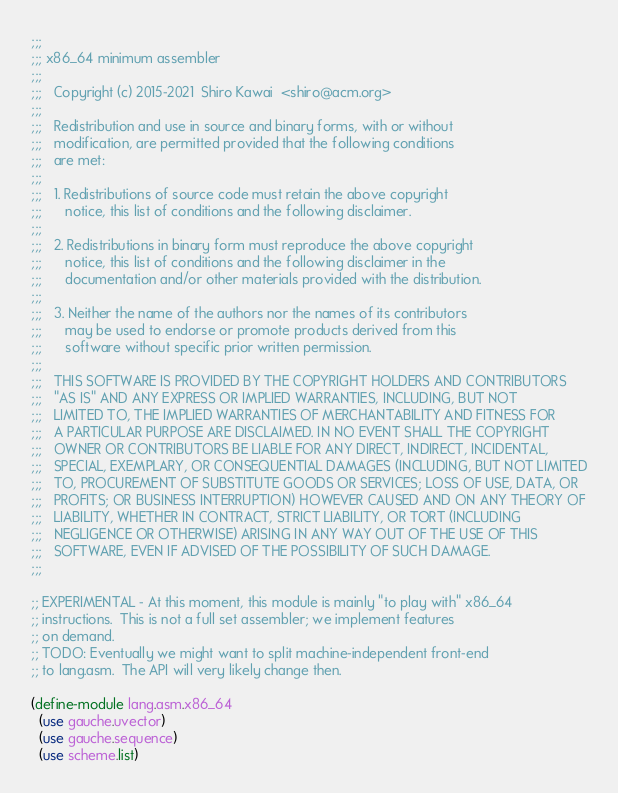<code> <loc_0><loc_0><loc_500><loc_500><_Scheme_>;;;
;;; x86_64 minimum assembler
;;;
;;;   Copyright (c) 2015-2021  Shiro Kawai  <shiro@acm.org>
;;;
;;;   Redistribution and use in source and binary forms, with or without
;;;   modification, are permitted provided that the following conditions
;;;   are met:
;;;
;;;   1. Redistributions of source code must retain the above copyright
;;;      notice, this list of conditions and the following disclaimer.
;;;
;;;   2. Redistributions in binary form must reproduce the above copyright
;;;      notice, this list of conditions and the following disclaimer in the
;;;      documentation and/or other materials provided with the distribution.
;;;
;;;   3. Neither the name of the authors nor the names of its contributors
;;;      may be used to endorse or promote products derived from this
;;;      software without specific prior written permission.
;;;
;;;   THIS SOFTWARE IS PROVIDED BY THE COPYRIGHT HOLDERS AND CONTRIBUTORS
;;;   "AS IS" AND ANY EXPRESS OR IMPLIED WARRANTIES, INCLUDING, BUT NOT
;;;   LIMITED TO, THE IMPLIED WARRANTIES OF MERCHANTABILITY AND FITNESS FOR
;;;   A PARTICULAR PURPOSE ARE DISCLAIMED. IN NO EVENT SHALL THE COPYRIGHT
;;;   OWNER OR CONTRIBUTORS BE LIABLE FOR ANY DIRECT, INDIRECT, INCIDENTAL,
;;;   SPECIAL, EXEMPLARY, OR CONSEQUENTIAL DAMAGES (INCLUDING, BUT NOT LIMITED
;;;   TO, PROCUREMENT OF SUBSTITUTE GOODS OR SERVICES; LOSS OF USE, DATA, OR
;;;   PROFITS; OR BUSINESS INTERRUPTION) HOWEVER CAUSED AND ON ANY THEORY OF
;;;   LIABILITY, WHETHER IN CONTRACT, STRICT LIABILITY, OR TORT (INCLUDING
;;;   NEGLIGENCE OR OTHERWISE) ARISING IN ANY WAY OUT OF THE USE OF THIS
;;;   SOFTWARE, EVEN IF ADVISED OF THE POSSIBILITY OF SUCH DAMAGE.
;;;

;; EXPERIMENTAL - At this moment, this module is mainly "to play with" x86_64
;; instructions.  This is not a full set assembler; we implement features
;; on demand.
;; TODO: Eventually we might want to split machine-independent front-end
;; to lang.asm.  The API will very likely change then.

(define-module lang.asm.x86_64
  (use gauche.uvector)
  (use gauche.sequence)
  (use scheme.list)</code> 